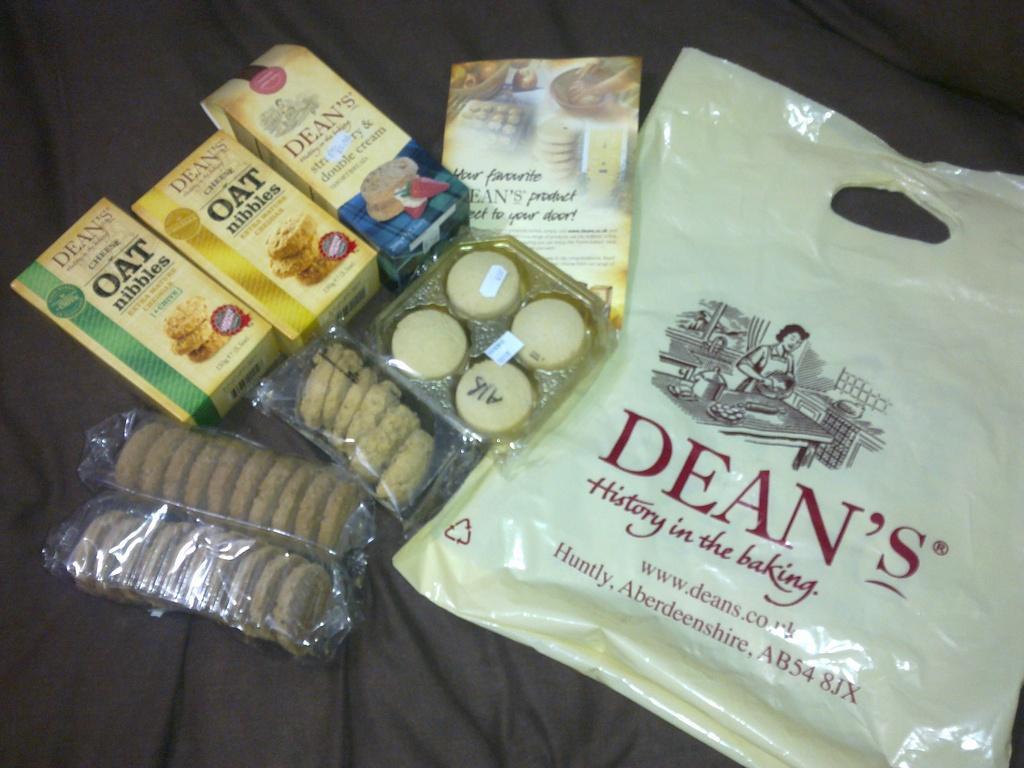Could you give a brief overview of what you see in this image? In this picture there are boxes of biscuits and oats which are placed on the left side of the image and there is a baking cover on the right side of the image. 